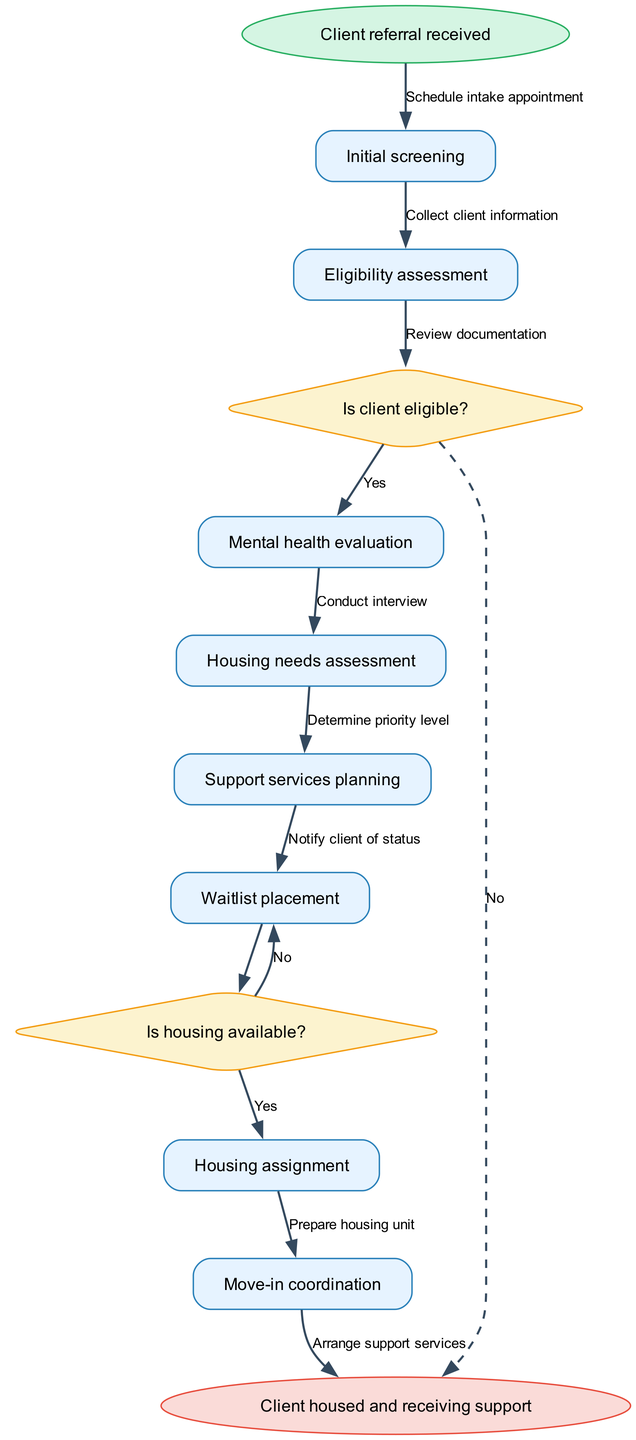What is the starting point of the process? The diagram begins with the node labeled "Client referral received," which indicates the initiation of the client intake process.
Answer: Client referral received How many nodes are present in the diagram? The diagram contains a total of 8 nodes, including the start and end nodes, and 6 process nodes representing different steps in the intake process.
Answer: 8 What follows after the initial screening? After the "Initial screening," the next node in the process is "Eligibility assessment," marking the following step in the client intake sequence.
Answer: Eligibility assessment What decision is made after the eligibility assessment? The decision made following the "Eligibility assessment" is "Is client eligible?" which determines whether the client can proceed further in the process.
Answer: Is client eligible? What happens if the client is not eligible? If the client is not eligible, the process moves to the end node, signifying that they will not continue to housing services. This is indicated by a dashed edge leading from the "Is client eligible?" decision to the end node.
Answer: Client housed and receiving support How many edges are there in total? There are 8 edges in the diagram, representing the connections between the various nodes and the transitions through the different stages of the client intake process.
Answer: 8 What action follows a successful eligibility assessment? Following a successful "Eligibility assessment," the next action taken is conducting a "Mental health evaluation," which helps further assess the client's needs.
Answer: Mental health evaluation In what scenario does the process revisit a previous node? The process revisits the "Waitlist placement" node if there is no housing availability, as shown by the edge labeled 'No' leading back to "Waitlist placement."
Answer: Waitlist placement 